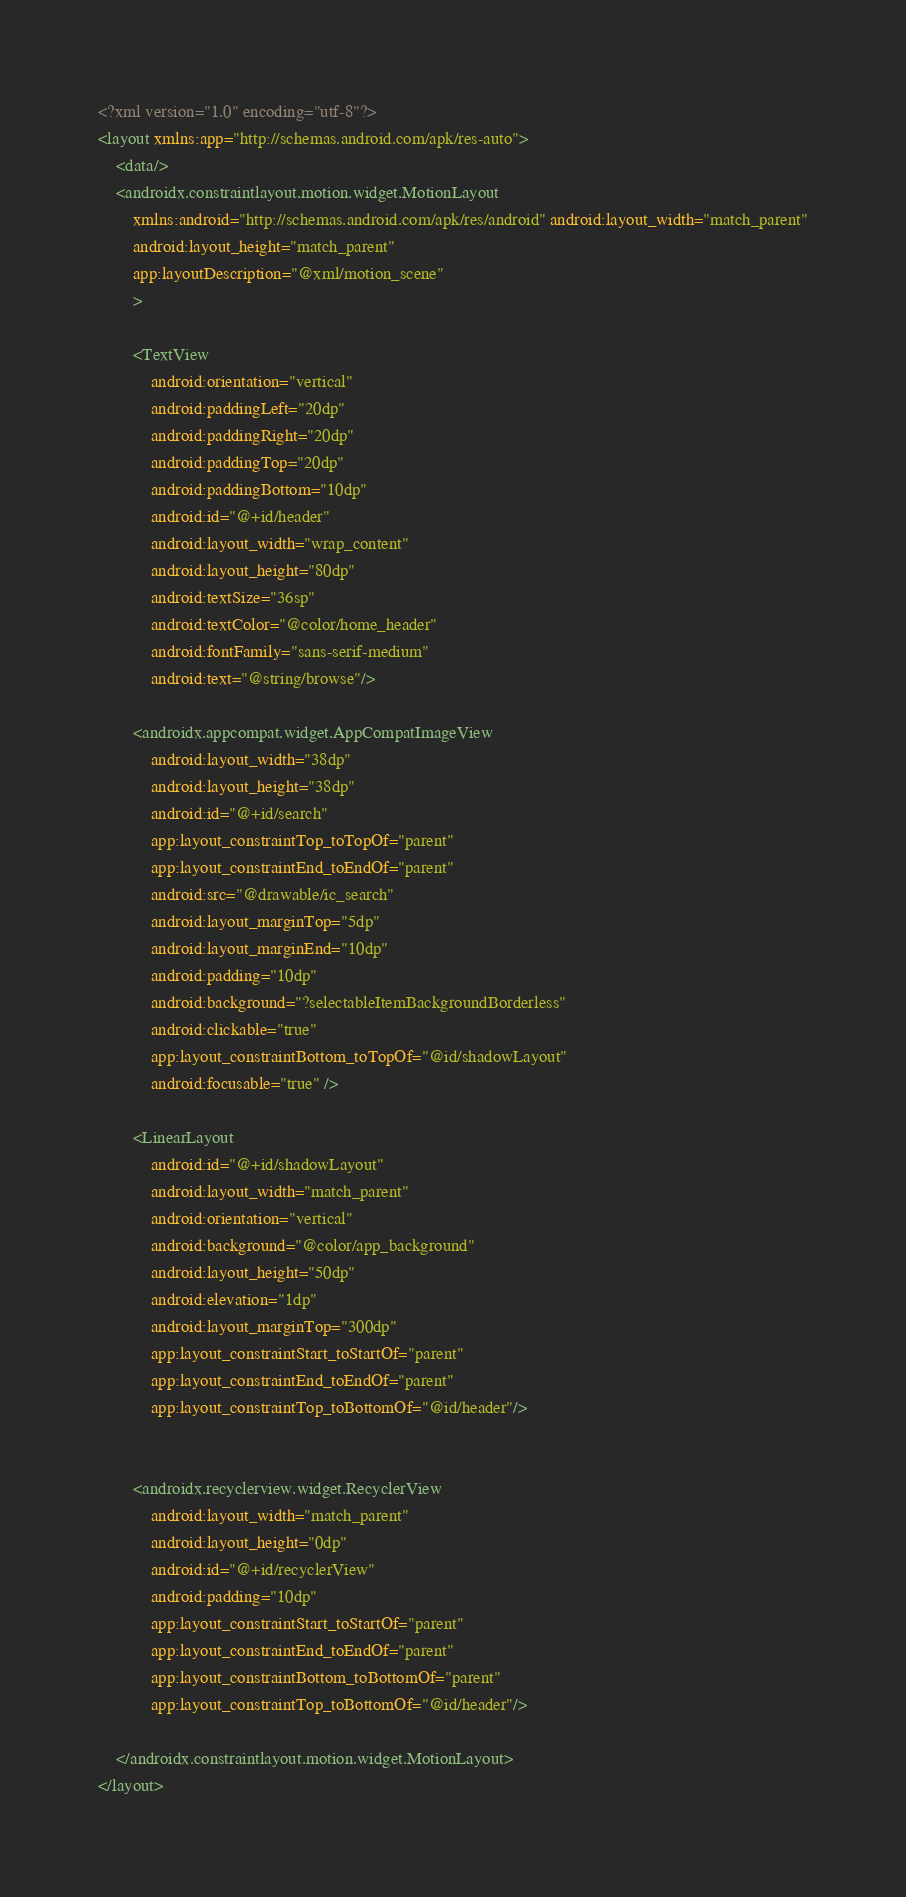Convert code to text. <code><loc_0><loc_0><loc_500><loc_500><_XML_><?xml version="1.0" encoding="utf-8"?>
<layout xmlns:app="http://schemas.android.com/apk/res-auto">
    <data/>
    <androidx.constraintlayout.motion.widget.MotionLayout
        xmlns:android="http://schemas.android.com/apk/res/android" android:layout_width="match_parent"
        android:layout_height="match_parent"
        app:layoutDescription="@xml/motion_scene"
        >

        <TextView
            android:orientation="vertical"
            android:paddingLeft="20dp"
            android:paddingRight="20dp"
            android:paddingTop="20dp"
            android:paddingBottom="10dp"
            android:id="@+id/header"
            android:layout_width="wrap_content"
            android:layout_height="80dp"
            android:textSize="36sp"
            android:textColor="@color/home_header"
            android:fontFamily="sans-serif-medium"
            android:text="@string/browse"/>

        <androidx.appcompat.widget.AppCompatImageView
            android:layout_width="38dp"
            android:layout_height="38dp"
            android:id="@+id/search"
            app:layout_constraintTop_toTopOf="parent"
            app:layout_constraintEnd_toEndOf="parent"
            android:src="@drawable/ic_search"
            android:layout_marginTop="5dp"
            android:layout_marginEnd="10dp"
            android:padding="10dp"
            android:background="?selectableItemBackgroundBorderless"
            android:clickable="true"
            app:layout_constraintBottom_toTopOf="@id/shadowLayout"
            android:focusable="true" />

        <LinearLayout
            android:id="@+id/shadowLayout"
            android:layout_width="match_parent"
            android:orientation="vertical"
            android:background="@color/app_background"
            android:layout_height="50dp"
            android:elevation="1dp"
            android:layout_marginTop="300dp"
            app:layout_constraintStart_toStartOf="parent"
            app:layout_constraintEnd_toEndOf="parent"
            app:layout_constraintTop_toBottomOf="@id/header"/>


        <androidx.recyclerview.widget.RecyclerView
            android:layout_width="match_parent"
            android:layout_height="0dp"
            android:id="@+id/recyclerView"
            android:padding="10dp"
            app:layout_constraintStart_toStartOf="parent"
            app:layout_constraintEnd_toEndOf="parent"
            app:layout_constraintBottom_toBottomOf="parent"
            app:layout_constraintTop_toBottomOf="@id/header"/>

    </androidx.constraintlayout.motion.widget.MotionLayout>
</layout></code> 